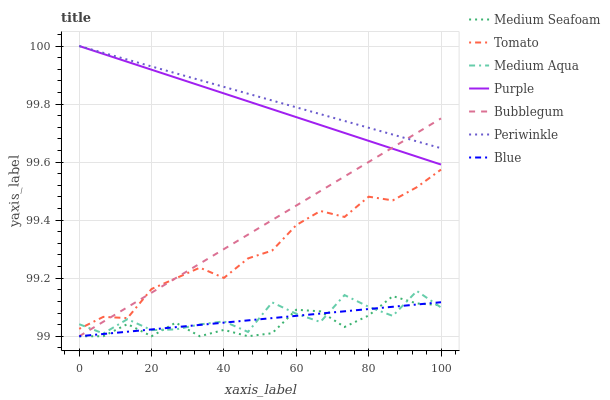Does Medium Seafoam have the minimum area under the curve?
Answer yes or no. Yes. Does Periwinkle have the maximum area under the curve?
Answer yes or no. Yes. Does Blue have the minimum area under the curve?
Answer yes or no. No. Does Blue have the maximum area under the curve?
Answer yes or no. No. Is Blue the smoothest?
Answer yes or no. Yes. Is Medium Aqua the roughest?
Answer yes or no. Yes. Is Purple the smoothest?
Answer yes or no. No. Is Purple the roughest?
Answer yes or no. No. Does Blue have the lowest value?
Answer yes or no. Yes. Does Purple have the lowest value?
Answer yes or no. No. Does Periwinkle have the highest value?
Answer yes or no. Yes. Does Blue have the highest value?
Answer yes or no. No. Is Medium Seafoam less than Tomato?
Answer yes or no. Yes. Is Tomato greater than Medium Seafoam?
Answer yes or no. Yes. Does Bubblegum intersect Purple?
Answer yes or no. Yes. Is Bubblegum less than Purple?
Answer yes or no. No. Is Bubblegum greater than Purple?
Answer yes or no. No. Does Medium Seafoam intersect Tomato?
Answer yes or no. No. 